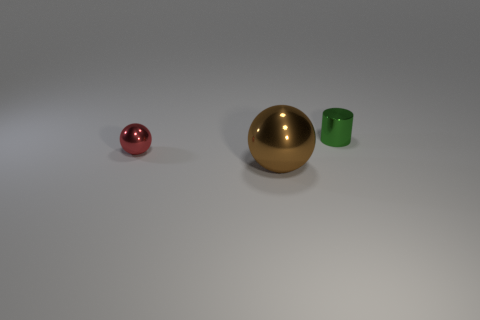Do the tiny metal thing in front of the tiny green metallic cylinder and the small metal object that is to the right of the big brown ball have the same shape? No, the two objects do not have the same shape. The small metal object in front of the green metallic cylinder is cylindrical, whereas the metal object to the right of the large brown ball is spherical. 